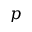<formula> <loc_0><loc_0><loc_500><loc_500>p</formula> 